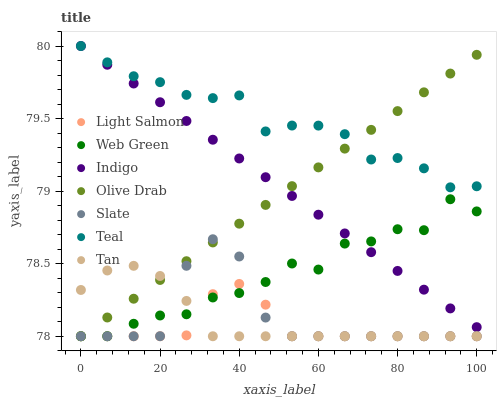Does Light Salmon have the minimum area under the curve?
Answer yes or no. Yes. Does Teal have the maximum area under the curve?
Answer yes or no. Yes. Does Indigo have the minimum area under the curve?
Answer yes or no. No. Does Indigo have the maximum area under the curve?
Answer yes or no. No. Is Olive Drab the smoothest?
Answer yes or no. Yes. Is Slate the roughest?
Answer yes or no. Yes. Is Indigo the smoothest?
Answer yes or no. No. Is Indigo the roughest?
Answer yes or no. No. Does Light Salmon have the lowest value?
Answer yes or no. Yes. Does Indigo have the lowest value?
Answer yes or no. No. Does Teal have the highest value?
Answer yes or no. Yes. Does Slate have the highest value?
Answer yes or no. No. Is Slate less than Indigo?
Answer yes or no. Yes. Is Teal greater than Tan?
Answer yes or no. Yes. Does Web Green intersect Slate?
Answer yes or no. Yes. Is Web Green less than Slate?
Answer yes or no. No. Is Web Green greater than Slate?
Answer yes or no. No. Does Slate intersect Indigo?
Answer yes or no. No. 